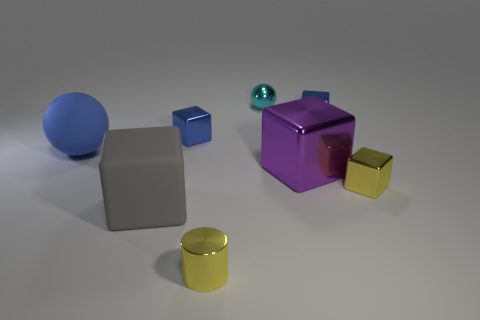Subtract all large metallic cubes. How many cubes are left? 4 Subtract all purple cubes. How many cubes are left? 4 Subtract all brown blocks. Subtract all yellow cylinders. How many blocks are left? 5 Add 1 gray cubes. How many objects exist? 9 Subtract all cylinders. How many objects are left? 7 Subtract all tiny cylinders. Subtract all matte things. How many objects are left? 5 Add 2 metallic balls. How many metallic balls are left? 3 Add 5 large brown metallic spheres. How many large brown metallic spheres exist? 5 Subtract 0 brown cylinders. How many objects are left? 8 